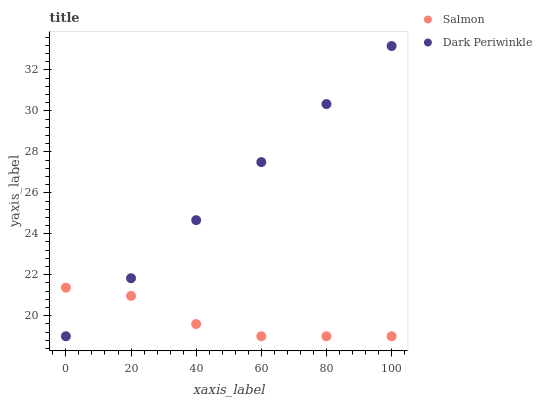Does Salmon have the minimum area under the curve?
Answer yes or no. Yes. Does Dark Periwinkle have the maximum area under the curve?
Answer yes or no. Yes. Does Dark Periwinkle have the minimum area under the curve?
Answer yes or no. No. Is Dark Periwinkle the smoothest?
Answer yes or no. Yes. Is Salmon the roughest?
Answer yes or no. Yes. Is Dark Periwinkle the roughest?
Answer yes or no. No. Does Salmon have the lowest value?
Answer yes or no. Yes. Does Dark Periwinkle have the highest value?
Answer yes or no. Yes. Does Salmon intersect Dark Periwinkle?
Answer yes or no. Yes. Is Salmon less than Dark Periwinkle?
Answer yes or no. No. Is Salmon greater than Dark Periwinkle?
Answer yes or no. No. 